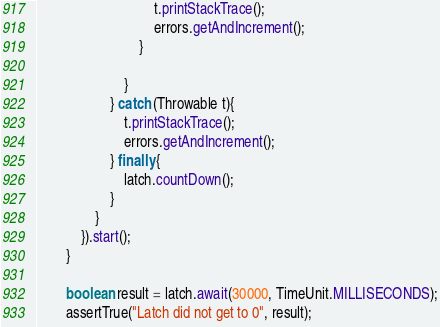<code> <loc_0><loc_0><loc_500><loc_500><_Java_>                                t.printStackTrace();
                                errors.getAndIncrement();
                            }

                        }
                    } catch (Throwable t){
                        t.printStackTrace();
                        errors.getAndIncrement();
                    } finally {
                        latch.countDown();
                    }
                }
            }).start();
        }

        boolean result = latch.await(30000, TimeUnit.MILLISECONDS);
        assertTrue("Latch did not get to 0", result);</code> 